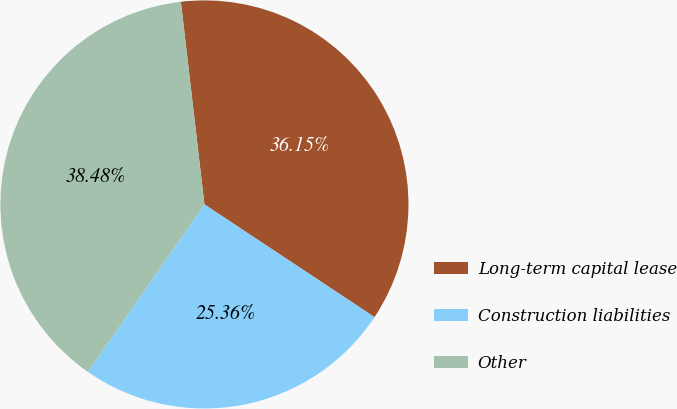Convert chart to OTSL. <chart><loc_0><loc_0><loc_500><loc_500><pie_chart><fcel>Long-term capital lease<fcel>Construction liabilities<fcel>Other<nl><fcel>36.15%<fcel>25.36%<fcel>38.48%<nl></chart> 